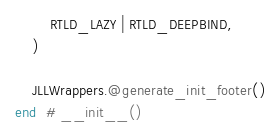Convert code to text. <code><loc_0><loc_0><loc_500><loc_500><_Julia_>        RTLD_LAZY | RTLD_DEEPBIND,
    )

    JLLWrappers.@generate_init_footer()
end  # __init__()
</code> 